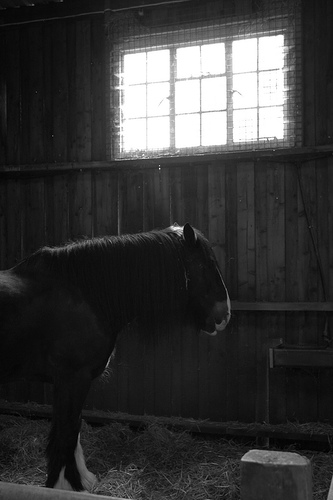<image>Is the wall made of wood? I don't know if the wall is made of wood. Is the wall made of wood? I am not sure if the wall is made of wood. It can be made of wood, but I cannot confirm it. 